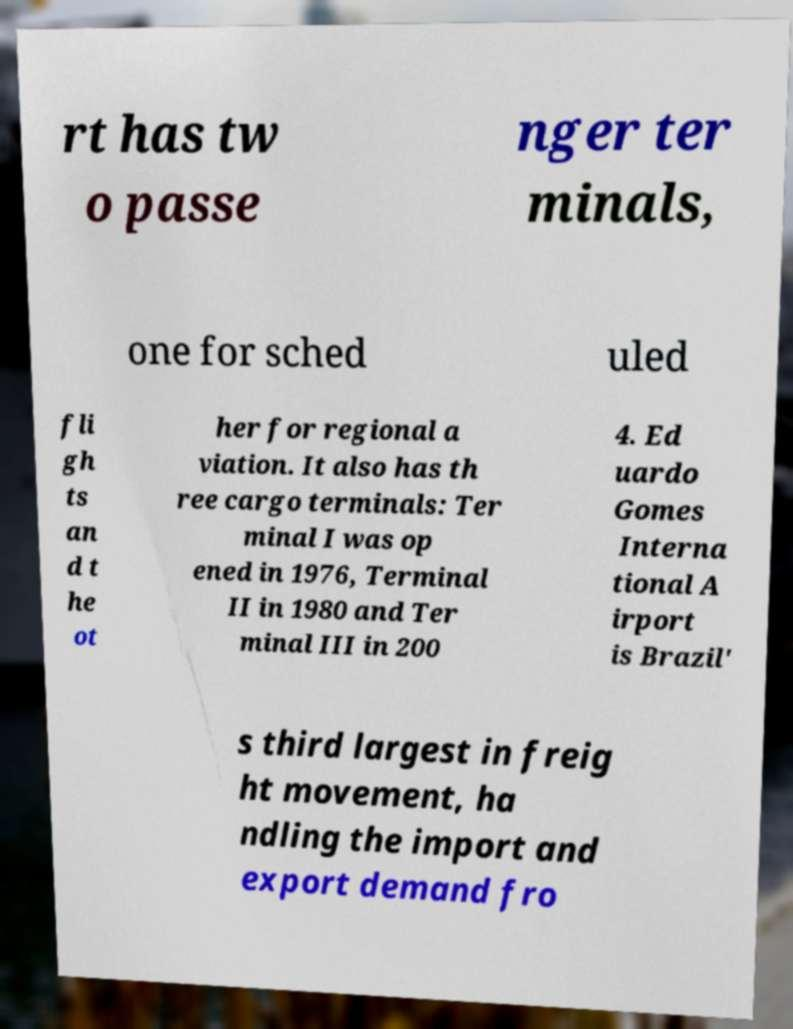Please read and relay the text visible in this image. What does it say? rt has tw o passe nger ter minals, one for sched uled fli gh ts an d t he ot her for regional a viation. It also has th ree cargo terminals: Ter minal I was op ened in 1976, Terminal II in 1980 and Ter minal III in 200 4. Ed uardo Gomes Interna tional A irport is Brazil' s third largest in freig ht movement, ha ndling the import and export demand fro 